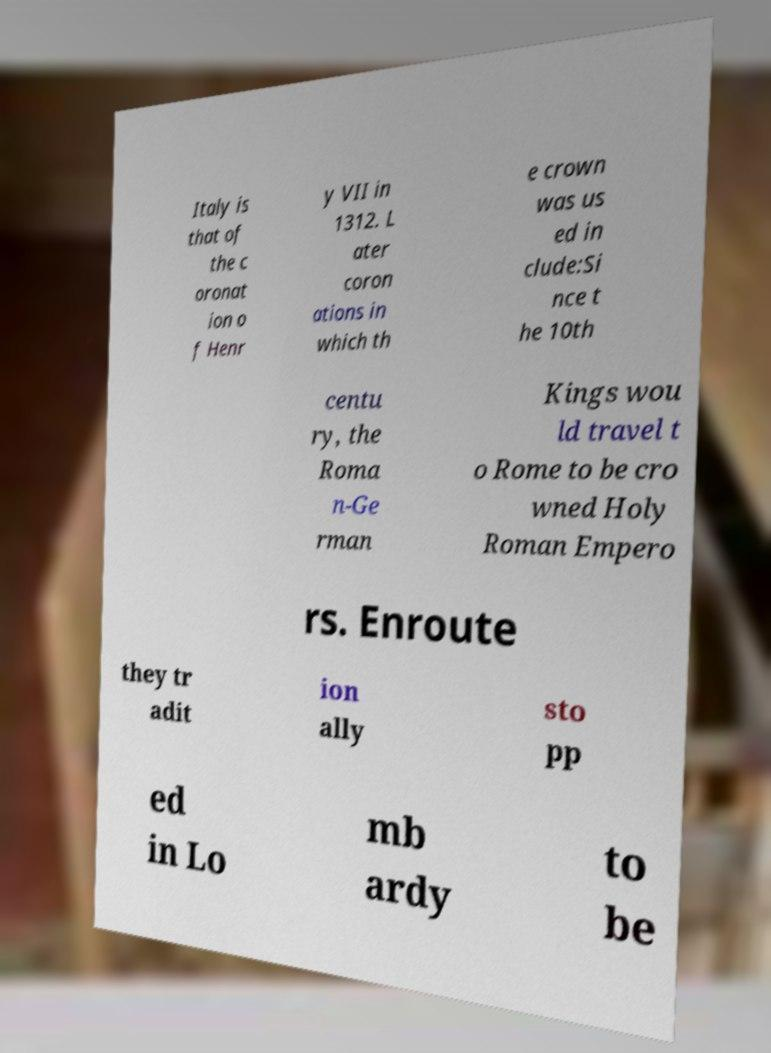Can you read and provide the text displayed in the image?This photo seems to have some interesting text. Can you extract and type it out for me? Italy is that of the c oronat ion o f Henr y VII in 1312. L ater coron ations in which th e crown was us ed in clude:Si nce t he 10th centu ry, the Roma n-Ge rman Kings wou ld travel t o Rome to be cro wned Holy Roman Empero rs. Enroute they tr adit ion ally sto pp ed in Lo mb ardy to be 